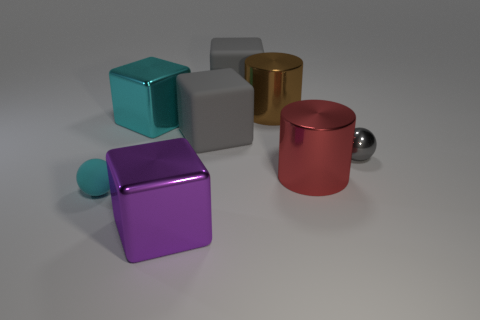Is the tiny ball to the left of the small gray metallic object made of the same material as the small sphere that is right of the big purple metallic object?
Make the answer very short. No. What size is the cylinder that is behind the tiny gray shiny object?
Make the answer very short. Large. The gray ball is what size?
Give a very brief answer. Small. What size is the metallic object that is behind the large cube left of the thing in front of the small rubber thing?
Provide a succinct answer. Large. Are there any big red cylinders made of the same material as the small gray thing?
Offer a terse response. Yes. What is the shape of the purple thing?
Keep it short and to the point. Cube. There is another block that is made of the same material as the purple block; what is its color?
Offer a terse response. Cyan. How many cyan objects are small metal balls or cylinders?
Your response must be concise. 0. Is the number of objects greater than the number of tiny gray balls?
Offer a very short reply. Yes. What number of objects are either large objects that are behind the tiny matte object or metallic things that are behind the small rubber thing?
Ensure brevity in your answer.  6. 